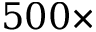Convert formula to latex. <formula><loc_0><loc_0><loc_500><loc_500>5 0 0 \times</formula> 